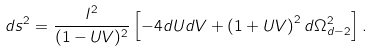<formula> <loc_0><loc_0><loc_500><loc_500>d s ^ { 2 } = \frac { l ^ { 2 } } { ( 1 - U V ) ^ { 2 } } \left [ - 4 d U d V + \left ( { 1 + U V } \right ) ^ { 2 } d \Omega _ { d - 2 } ^ { 2 } \right ] .</formula> 